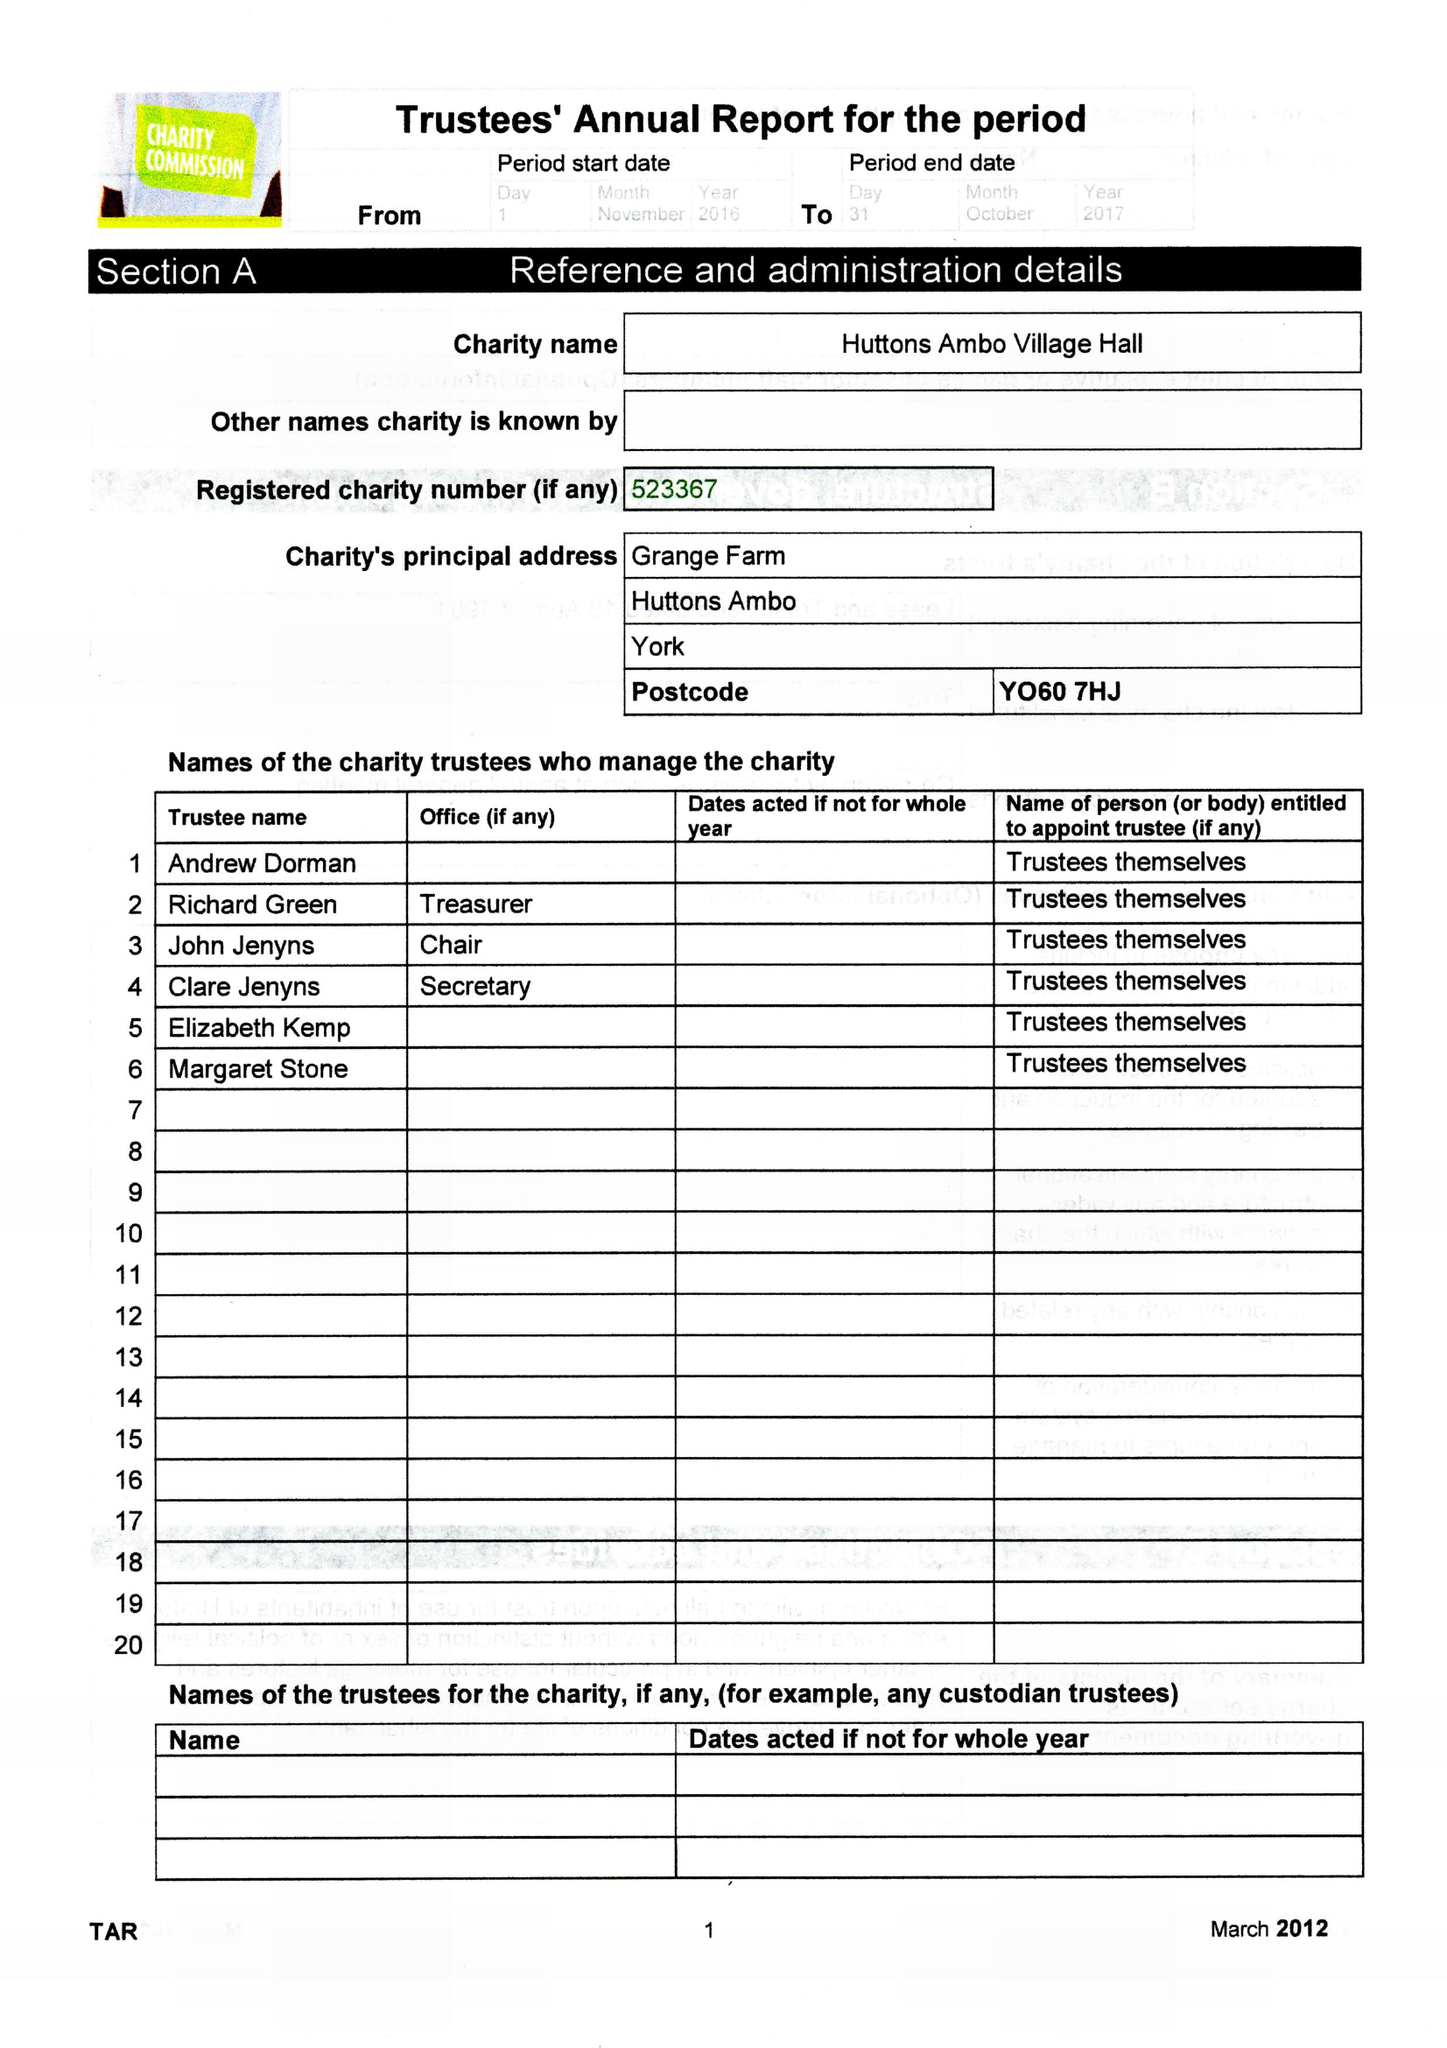What is the value for the charity_name?
Answer the question using a single word or phrase. Huttons Ambo Village Hall 